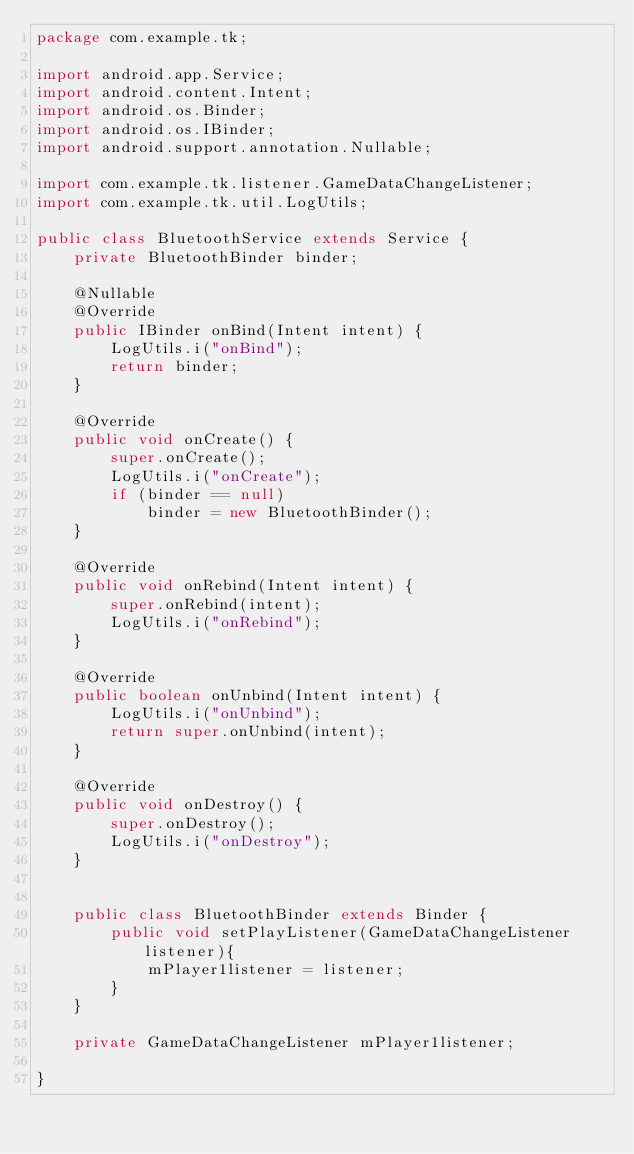<code> <loc_0><loc_0><loc_500><loc_500><_Java_>package com.example.tk;

import android.app.Service;
import android.content.Intent;
import android.os.Binder;
import android.os.IBinder;
import android.support.annotation.Nullable;

import com.example.tk.listener.GameDataChangeListener;
import com.example.tk.util.LogUtils;

public class BluetoothService extends Service {
    private BluetoothBinder binder;

    @Nullable
    @Override
    public IBinder onBind(Intent intent) {
        LogUtils.i("onBind");
        return binder;
    }

    @Override
    public void onCreate() {
        super.onCreate();
        LogUtils.i("onCreate");
        if (binder == null)
            binder = new BluetoothBinder();
    }

    @Override
    public void onRebind(Intent intent) {
        super.onRebind(intent);
        LogUtils.i("onRebind");
    }

    @Override
    public boolean onUnbind(Intent intent) {
        LogUtils.i("onUnbind");
        return super.onUnbind(intent);
    }

    @Override
    public void onDestroy() {
        super.onDestroy();
        LogUtils.i("onDestroy");
    }


    public class BluetoothBinder extends Binder {
        public void setPlayListener(GameDataChangeListener listener){
            mPlayer1listener = listener;
        }
    }

    private GameDataChangeListener mPlayer1listener;

}
</code> 